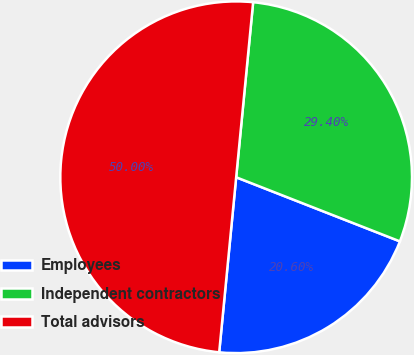Convert chart to OTSL. <chart><loc_0><loc_0><loc_500><loc_500><pie_chart><fcel>Employees<fcel>Independent contractors<fcel>Total advisors<nl><fcel>20.6%<fcel>29.4%<fcel>50.0%<nl></chart> 